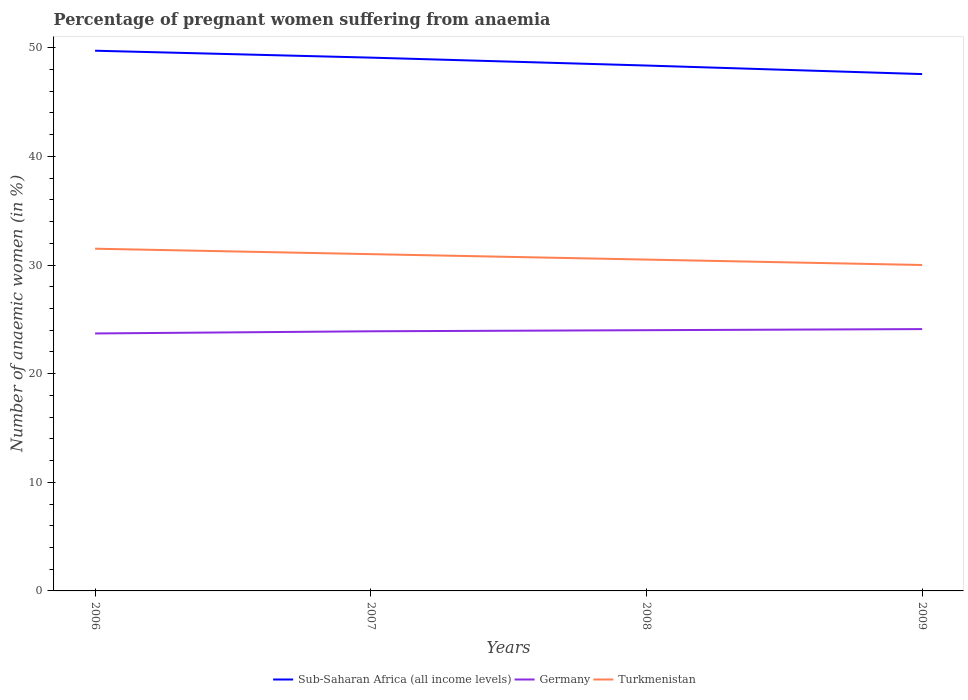How many different coloured lines are there?
Your answer should be very brief. 3. Across all years, what is the maximum number of anaemic women in Turkmenistan?
Offer a terse response. 30. In which year was the number of anaemic women in Turkmenistan maximum?
Offer a terse response. 2009. What is the total number of anaemic women in Sub-Saharan Africa (all income levels) in the graph?
Provide a succinct answer. 0.79. What is the difference between the highest and the second highest number of anaemic women in Turkmenistan?
Make the answer very short. 1.5. What is the difference between the highest and the lowest number of anaemic women in Sub-Saharan Africa (all income levels)?
Make the answer very short. 2. Is the number of anaemic women in Turkmenistan strictly greater than the number of anaemic women in Sub-Saharan Africa (all income levels) over the years?
Your answer should be compact. Yes. How many lines are there?
Your answer should be compact. 3. Does the graph contain any zero values?
Provide a short and direct response. No. Does the graph contain grids?
Your response must be concise. No. Where does the legend appear in the graph?
Keep it short and to the point. Bottom center. How many legend labels are there?
Your response must be concise. 3. What is the title of the graph?
Your response must be concise. Percentage of pregnant women suffering from anaemia. Does "Grenada" appear as one of the legend labels in the graph?
Make the answer very short. No. What is the label or title of the X-axis?
Your answer should be very brief. Years. What is the label or title of the Y-axis?
Offer a terse response. Number of anaemic women (in %). What is the Number of anaemic women (in %) in Sub-Saharan Africa (all income levels) in 2006?
Keep it short and to the point. 49.73. What is the Number of anaemic women (in %) of Germany in 2006?
Offer a very short reply. 23.7. What is the Number of anaemic women (in %) in Turkmenistan in 2006?
Keep it short and to the point. 31.5. What is the Number of anaemic women (in %) in Sub-Saharan Africa (all income levels) in 2007?
Your answer should be very brief. 49.09. What is the Number of anaemic women (in %) in Germany in 2007?
Give a very brief answer. 23.9. What is the Number of anaemic women (in %) of Sub-Saharan Africa (all income levels) in 2008?
Ensure brevity in your answer.  48.36. What is the Number of anaemic women (in %) in Turkmenistan in 2008?
Offer a terse response. 30.5. What is the Number of anaemic women (in %) in Sub-Saharan Africa (all income levels) in 2009?
Your answer should be very brief. 47.57. What is the Number of anaemic women (in %) in Germany in 2009?
Make the answer very short. 24.1. What is the Number of anaemic women (in %) in Turkmenistan in 2009?
Your response must be concise. 30. Across all years, what is the maximum Number of anaemic women (in %) in Sub-Saharan Africa (all income levels)?
Your answer should be compact. 49.73. Across all years, what is the maximum Number of anaemic women (in %) in Germany?
Your answer should be very brief. 24.1. Across all years, what is the maximum Number of anaemic women (in %) of Turkmenistan?
Keep it short and to the point. 31.5. Across all years, what is the minimum Number of anaemic women (in %) of Sub-Saharan Africa (all income levels)?
Your answer should be compact. 47.57. Across all years, what is the minimum Number of anaemic women (in %) in Germany?
Offer a very short reply. 23.7. What is the total Number of anaemic women (in %) in Sub-Saharan Africa (all income levels) in the graph?
Offer a very short reply. 194.75. What is the total Number of anaemic women (in %) of Germany in the graph?
Your answer should be very brief. 95.7. What is the total Number of anaemic women (in %) of Turkmenistan in the graph?
Your answer should be very brief. 123. What is the difference between the Number of anaemic women (in %) of Sub-Saharan Africa (all income levels) in 2006 and that in 2007?
Make the answer very short. 0.64. What is the difference between the Number of anaemic women (in %) in Turkmenistan in 2006 and that in 2007?
Provide a short and direct response. 0.5. What is the difference between the Number of anaemic women (in %) in Sub-Saharan Africa (all income levels) in 2006 and that in 2008?
Your answer should be compact. 1.36. What is the difference between the Number of anaemic women (in %) in Sub-Saharan Africa (all income levels) in 2006 and that in 2009?
Your answer should be very brief. 2.15. What is the difference between the Number of anaemic women (in %) in Sub-Saharan Africa (all income levels) in 2007 and that in 2008?
Provide a short and direct response. 0.73. What is the difference between the Number of anaemic women (in %) of Turkmenistan in 2007 and that in 2008?
Ensure brevity in your answer.  0.5. What is the difference between the Number of anaemic women (in %) of Sub-Saharan Africa (all income levels) in 2007 and that in 2009?
Provide a short and direct response. 1.51. What is the difference between the Number of anaemic women (in %) in Germany in 2007 and that in 2009?
Keep it short and to the point. -0.2. What is the difference between the Number of anaemic women (in %) of Turkmenistan in 2007 and that in 2009?
Give a very brief answer. 1. What is the difference between the Number of anaemic women (in %) of Sub-Saharan Africa (all income levels) in 2008 and that in 2009?
Keep it short and to the point. 0.79. What is the difference between the Number of anaemic women (in %) in Germany in 2008 and that in 2009?
Your response must be concise. -0.1. What is the difference between the Number of anaemic women (in %) of Turkmenistan in 2008 and that in 2009?
Offer a very short reply. 0.5. What is the difference between the Number of anaemic women (in %) of Sub-Saharan Africa (all income levels) in 2006 and the Number of anaemic women (in %) of Germany in 2007?
Offer a terse response. 25.83. What is the difference between the Number of anaemic women (in %) of Sub-Saharan Africa (all income levels) in 2006 and the Number of anaemic women (in %) of Turkmenistan in 2007?
Provide a succinct answer. 18.73. What is the difference between the Number of anaemic women (in %) of Sub-Saharan Africa (all income levels) in 2006 and the Number of anaemic women (in %) of Germany in 2008?
Your answer should be compact. 25.73. What is the difference between the Number of anaemic women (in %) in Sub-Saharan Africa (all income levels) in 2006 and the Number of anaemic women (in %) in Turkmenistan in 2008?
Give a very brief answer. 19.23. What is the difference between the Number of anaemic women (in %) of Sub-Saharan Africa (all income levels) in 2006 and the Number of anaemic women (in %) of Germany in 2009?
Your answer should be compact. 25.63. What is the difference between the Number of anaemic women (in %) of Sub-Saharan Africa (all income levels) in 2006 and the Number of anaemic women (in %) of Turkmenistan in 2009?
Provide a short and direct response. 19.73. What is the difference between the Number of anaemic women (in %) in Germany in 2006 and the Number of anaemic women (in %) in Turkmenistan in 2009?
Give a very brief answer. -6.3. What is the difference between the Number of anaemic women (in %) of Sub-Saharan Africa (all income levels) in 2007 and the Number of anaemic women (in %) of Germany in 2008?
Ensure brevity in your answer.  25.09. What is the difference between the Number of anaemic women (in %) in Sub-Saharan Africa (all income levels) in 2007 and the Number of anaemic women (in %) in Turkmenistan in 2008?
Offer a very short reply. 18.59. What is the difference between the Number of anaemic women (in %) in Sub-Saharan Africa (all income levels) in 2007 and the Number of anaemic women (in %) in Germany in 2009?
Your answer should be very brief. 24.99. What is the difference between the Number of anaemic women (in %) of Sub-Saharan Africa (all income levels) in 2007 and the Number of anaemic women (in %) of Turkmenistan in 2009?
Offer a terse response. 19.09. What is the difference between the Number of anaemic women (in %) in Germany in 2007 and the Number of anaemic women (in %) in Turkmenistan in 2009?
Ensure brevity in your answer.  -6.1. What is the difference between the Number of anaemic women (in %) of Sub-Saharan Africa (all income levels) in 2008 and the Number of anaemic women (in %) of Germany in 2009?
Your answer should be compact. 24.26. What is the difference between the Number of anaemic women (in %) in Sub-Saharan Africa (all income levels) in 2008 and the Number of anaemic women (in %) in Turkmenistan in 2009?
Offer a terse response. 18.36. What is the average Number of anaemic women (in %) in Sub-Saharan Africa (all income levels) per year?
Offer a very short reply. 48.69. What is the average Number of anaemic women (in %) of Germany per year?
Keep it short and to the point. 23.93. What is the average Number of anaemic women (in %) in Turkmenistan per year?
Keep it short and to the point. 30.75. In the year 2006, what is the difference between the Number of anaemic women (in %) of Sub-Saharan Africa (all income levels) and Number of anaemic women (in %) of Germany?
Offer a terse response. 26.03. In the year 2006, what is the difference between the Number of anaemic women (in %) in Sub-Saharan Africa (all income levels) and Number of anaemic women (in %) in Turkmenistan?
Your response must be concise. 18.23. In the year 2006, what is the difference between the Number of anaemic women (in %) in Germany and Number of anaemic women (in %) in Turkmenistan?
Provide a succinct answer. -7.8. In the year 2007, what is the difference between the Number of anaemic women (in %) in Sub-Saharan Africa (all income levels) and Number of anaemic women (in %) in Germany?
Make the answer very short. 25.19. In the year 2007, what is the difference between the Number of anaemic women (in %) of Sub-Saharan Africa (all income levels) and Number of anaemic women (in %) of Turkmenistan?
Give a very brief answer. 18.09. In the year 2008, what is the difference between the Number of anaemic women (in %) in Sub-Saharan Africa (all income levels) and Number of anaemic women (in %) in Germany?
Your response must be concise. 24.36. In the year 2008, what is the difference between the Number of anaemic women (in %) of Sub-Saharan Africa (all income levels) and Number of anaemic women (in %) of Turkmenistan?
Your response must be concise. 17.86. In the year 2008, what is the difference between the Number of anaemic women (in %) in Germany and Number of anaemic women (in %) in Turkmenistan?
Provide a succinct answer. -6.5. In the year 2009, what is the difference between the Number of anaemic women (in %) of Sub-Saharan Africa (all income levels) and Number of anaemic women (in %) of Germany?
Offer a terse response. 23.48. In the year 2009, what is the difference between the Number of anaemic women (in %) in Sub-Saharan Africa (all income levels) and Number of anaemic women (in %) in Turkmenistan?
Provide a succinct answer. 17.57. In the year 2009, what is the difference between the Number of anaemic women (in %) in Germany and Number of anaemic women (in %) in Turkmenistan?
Your answer should be very brief. -5.9. What is the ratio of the Number of anaemic women (in %) in Germany in 2006 to that in 2007?
Make the answer very short. 0.99. What is the ratio of the Number of anaemic women (in %) of Turkmenistan in 2006 to that in 2007?
Offer a very short reply. 1.02. What is the ratio of the Number of anaemic women (in %) of Sub-Saharan Africa (all income levels) in 2006 to that in 2008?
Offer a very short reply. 1.03. What is the ratio of the Number of anaemic women (in %) of Germany in 2006 to that in 2008?
Offer a terse response. 0.99. What is the ratio of the Number of anaemic women (in %) in Turkmenistan in 2006 to that in 2008?
Your response must be concise. 1.03. What is the ratio of the Number of anaemic women (in %) in Sub-Saharan Africa (all income levels) in 2006 to that in 2009?
Offer a terse response. 1.05. What is the ratio of the Number of anaemic women (in %) in Germany in 2006 to that in 2009?
Your response must be concise. 0.98. What is the ratio of the Number of anaemic women (in %) of Germany in 2007 to that in 2008?
Offer a terse response. 1. What is the ratio of the Number of anaemic women (in %) in Turkmenistan in 2007 to that in 2008?
Provide a short and direct response. 1.02. What is the ratio of the Number of anaemic women (in %) in Sub-Saharan Africa (all income levels) in 2007 to that in 2009?
Your answer should be very brief. 1.03. What is the ratio of the Number of anaemic women (in %) in Sub-Saharan Africa (all income levels) in 2008 to that in 2009?
Provide a succinct answer. 1.02. What is the ratio of the Number of anaemic women (in %) in Germany in 2008 to that in 2009?
Your response must be concise. 1. What is the ratio of the Number of anaemic women (in %) of Turkmenistan in 2008 to that in 2009?
Give a very brief answer. 1.02. What is the difference between the highest and the second highest Number of anaemic women (in %) in Sub-Saharan Africa (all income levels)?
Give a very brief answer. 0.64. What is the difference between the highest and the second highest Number of anaemic women (in %) in Turkmenistan?
Make the answer very short. 0.5. What is the difference between the highest and the lowest Number of anaemic women (in %) in Sub-Saharan Africa (all income levels)?
Make the answer very short. 2.15. 